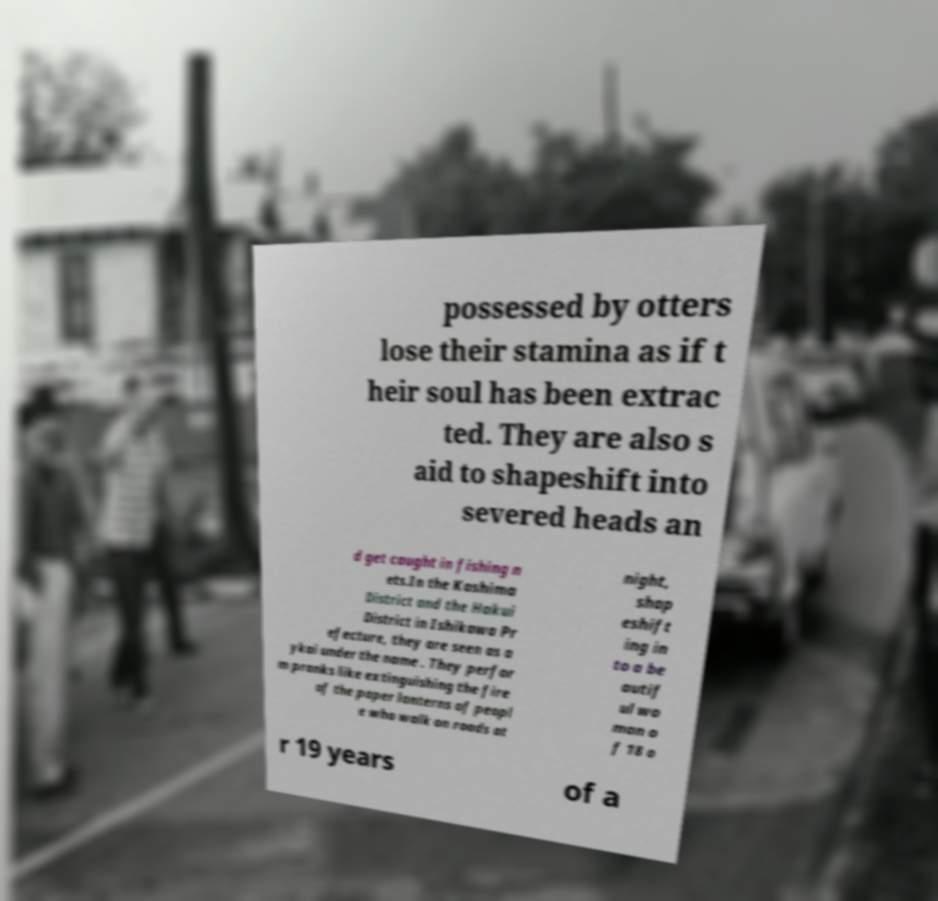Could you extract and type out the text from this image? possessed by otters lose their stamina as if t heir soul has been extrac ted. They are also s aid to shapeshift into severed heads an d get caught in fishing n ets.In the Kashima District and the Hakui District in Ishikawa Pr efecture, they are seen as a ykai under the name . They perfor m pranks like extinguishing the fire of the paper lanterns of peopl e who walk on roads at night, shap eshift ing in to a be autif ul wo man o f 18 o r 19 years of a 